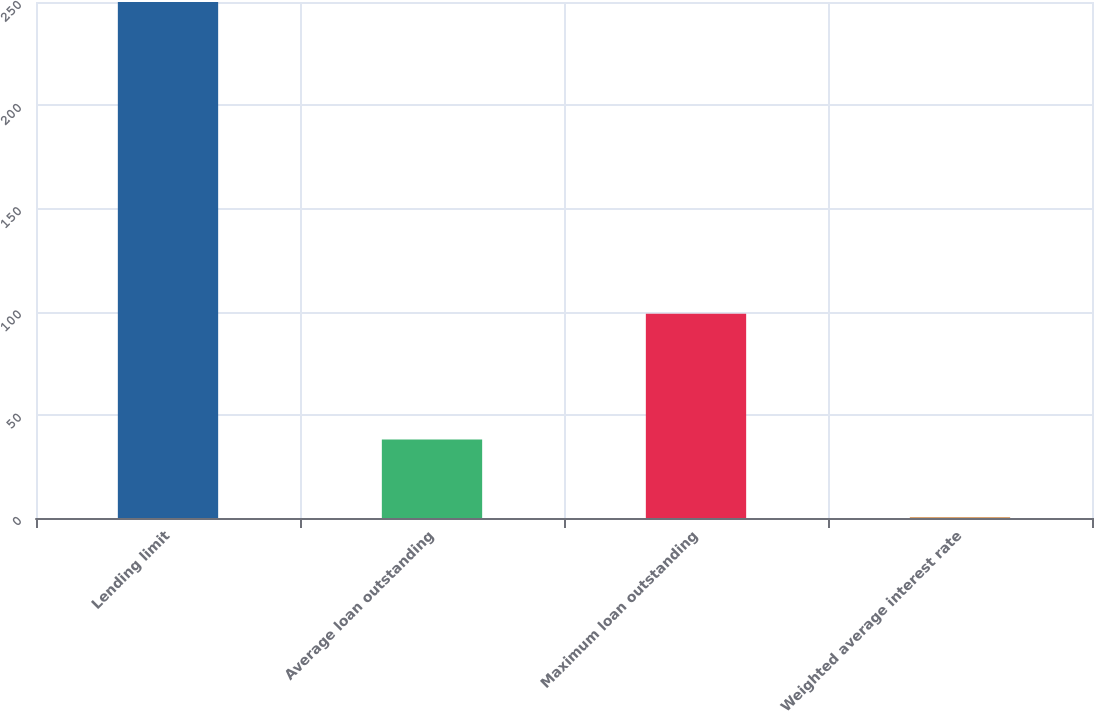<chart> <loc_0><loc_0><loc_500><loc_500><bar_chart><fcel>Lending limit<fcel>Average loan outstanding<fcel>Maximum loan outstanding<fcel>Weighted average interest rate<nl><fcel>250<fcel>38<fcel>99<fcel>0.38<nl></chart> 